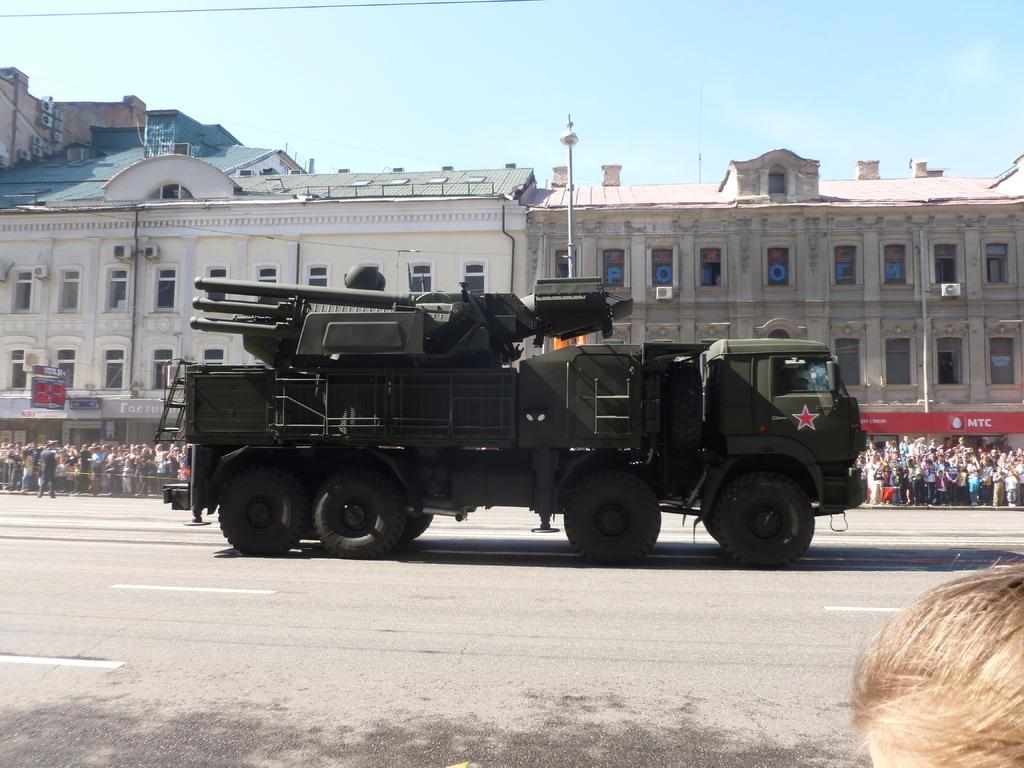What is the main subject of the image? There is a vehicle on the road in the image. What can be seen in the background of the image? There are buildings, persons, stores, and the sky visible in the background of the image. What type of lip can be seen on the vehicle in the image? There is no lip present on the vehicle in the image. How many beds are visible in the image? There are no beds visible in the image. 